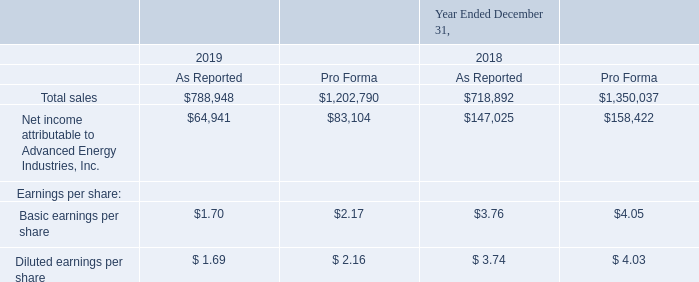ADVANCED ENERGY INDUSTRIES, INC. NOTES TO CONSOLIDATED FINANCIAL STATEMENTS – (continued) (in thousands, except per share amounts)
The following table presents our unaudited pro forma results for the acquisitions of Artesyn and LumaSense:
The unaudited pro forma results for all periods presented include adjustments made to account for certain costs and transactions that would have been incurred had the acquisitions been completed at the beginning of the year prior to the year of acquisition. These include adjustments to amortization charges for acquired intangible assets, interest and financing expenses, transaction costs, amortization of purchased gross profit and the alignment of various accounting policies. These adjustments are net of any applicable tax impact and were included to arrive at the pro forma results above.
Artesyn’s operating results have been included in the Advanced Energy’s operating results for the periods subsequent to the completion of the acquisition on September 10, 2019. During the year ended December 31, 2019, Artesyn contributed total sales of $220.3 million and net income of $7.1 million, including interest and other expense associated with the financing of the transaction.
What did the unaudited pro forma results for all periods presented include? Adjustments made to account for certain costs and transactions that would have been incurred had the acquisitions been completed at the beginning of the year prior to the year of acquisition. What was the total sales as reported in 2019?
Answer scale should be: thousand. $788,948. What does the table show? Unaudited pro forma results for the acquisitions of artesyn and lumasense. What was the change in Pro Forma total sales between 2018 and 2019?
Answer scale should be: thousand. $1,202,790-$1,350,037
Answer: -147247. What was the change in basic earnings per share as reported between 2018 and 2019? $1.70-$3.76
Answer: -2.06. What was the percentage change in Net income attributable to Advanced Energy Industries, Inc. as reported between 2018 and 2019
Answer scale should be: percent. ($64,941-$147,025)/$147,025
Answer: -55.83. 